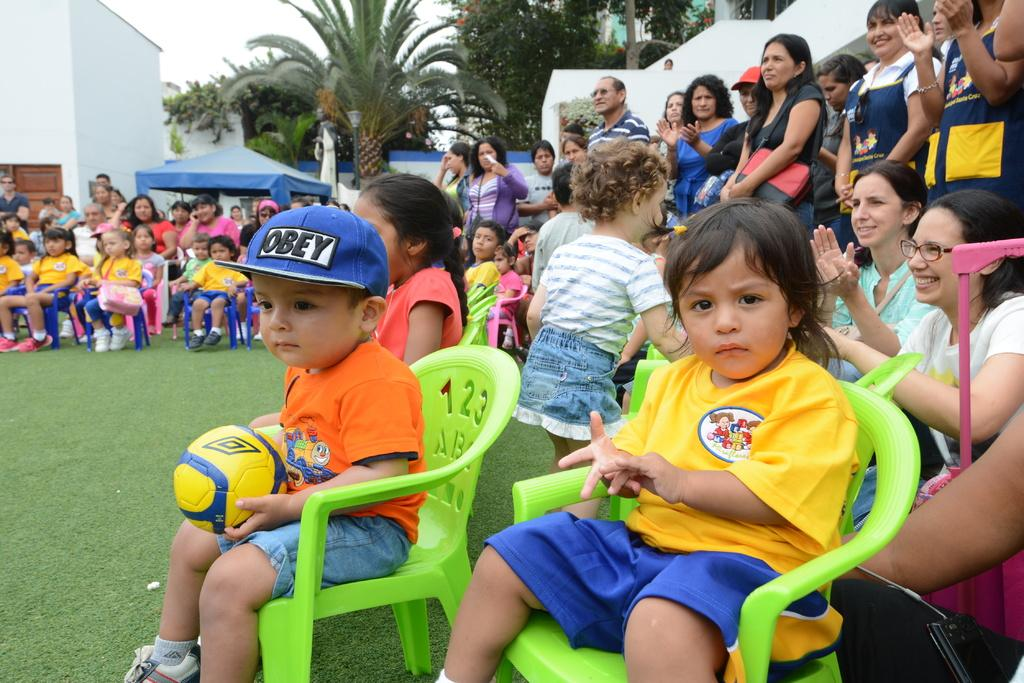What are the children in the image doing? The group of children is sitting on chairs in the image. What are the other persons in the image doing? There is a group of persons standing on the grass in the image. What type of vegetation can be seen in the image? Trees are present in the image. What is visible in the background of the image? The sky is visible in the image. What type of cake is being attacked by the children in the image? There is no cake present in the image, and the children are not attacking anything. 